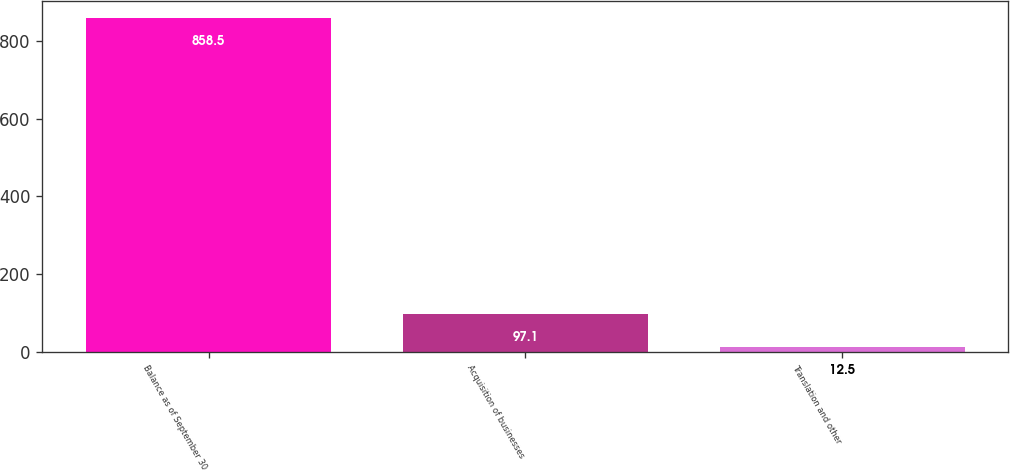<chart> <loc_0><loc_0><loc_500><loc_500><bar_chart><fcel>Balance as of September 30<fcel>Acquisition of businesses<fcel>Translation and other<nl><fcel>858.5<fcel>97.1<fcel>12.5<nl></chart> 